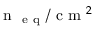Convert formula to latex. <formula><loc_0><loc_0><loc_500><loc_500>n _ { e q } / c m ^ { 2 }</formula> 